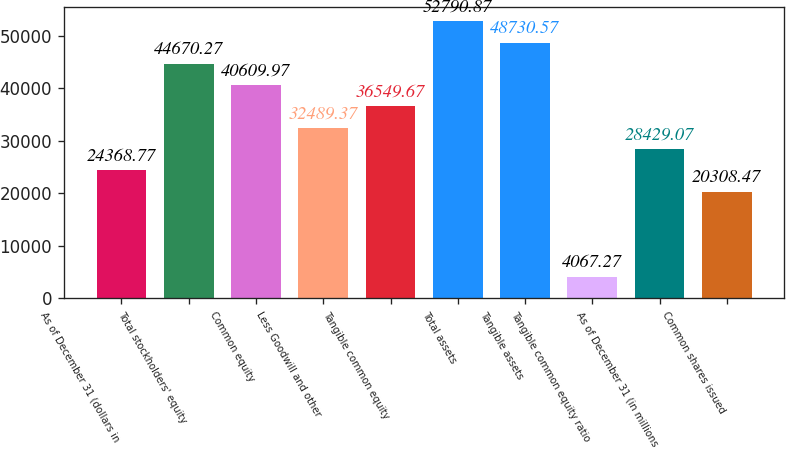<chart> <loc_0><loc_0><loc_500><loc_500><bar_chart><fcel>As of December 31 (dollars in<fcel>Total stockholders' equity<fcel>Common equity<fcel>Less Goodwill and other<fcel>Tangible common equity<fcel>Total assets<fcel>Tangible assets<fcel>Tangible common equity ratio<fcel>As of December 31 (in millions<fcel>Common shares issued<nl><fcel>24368.8<fcel>44670.3<fcel>40610<fcel>32489.4<fcel>36549.7<fcel>52790.9<fcel>48730.6<fcel>4067.27<fcel>28429.1<fcel>20308.5<nl></chart> 